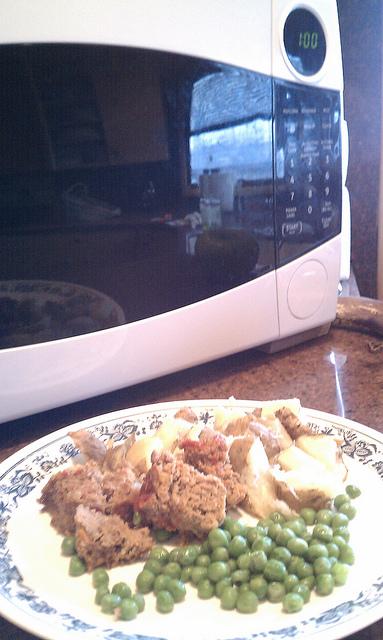What are the brown items on the plate?
Quick response, please. Meat. How many different foods are on the plate?
Concise answer only. 3. What are those round green things?
Give a very brief answer. Peas. 